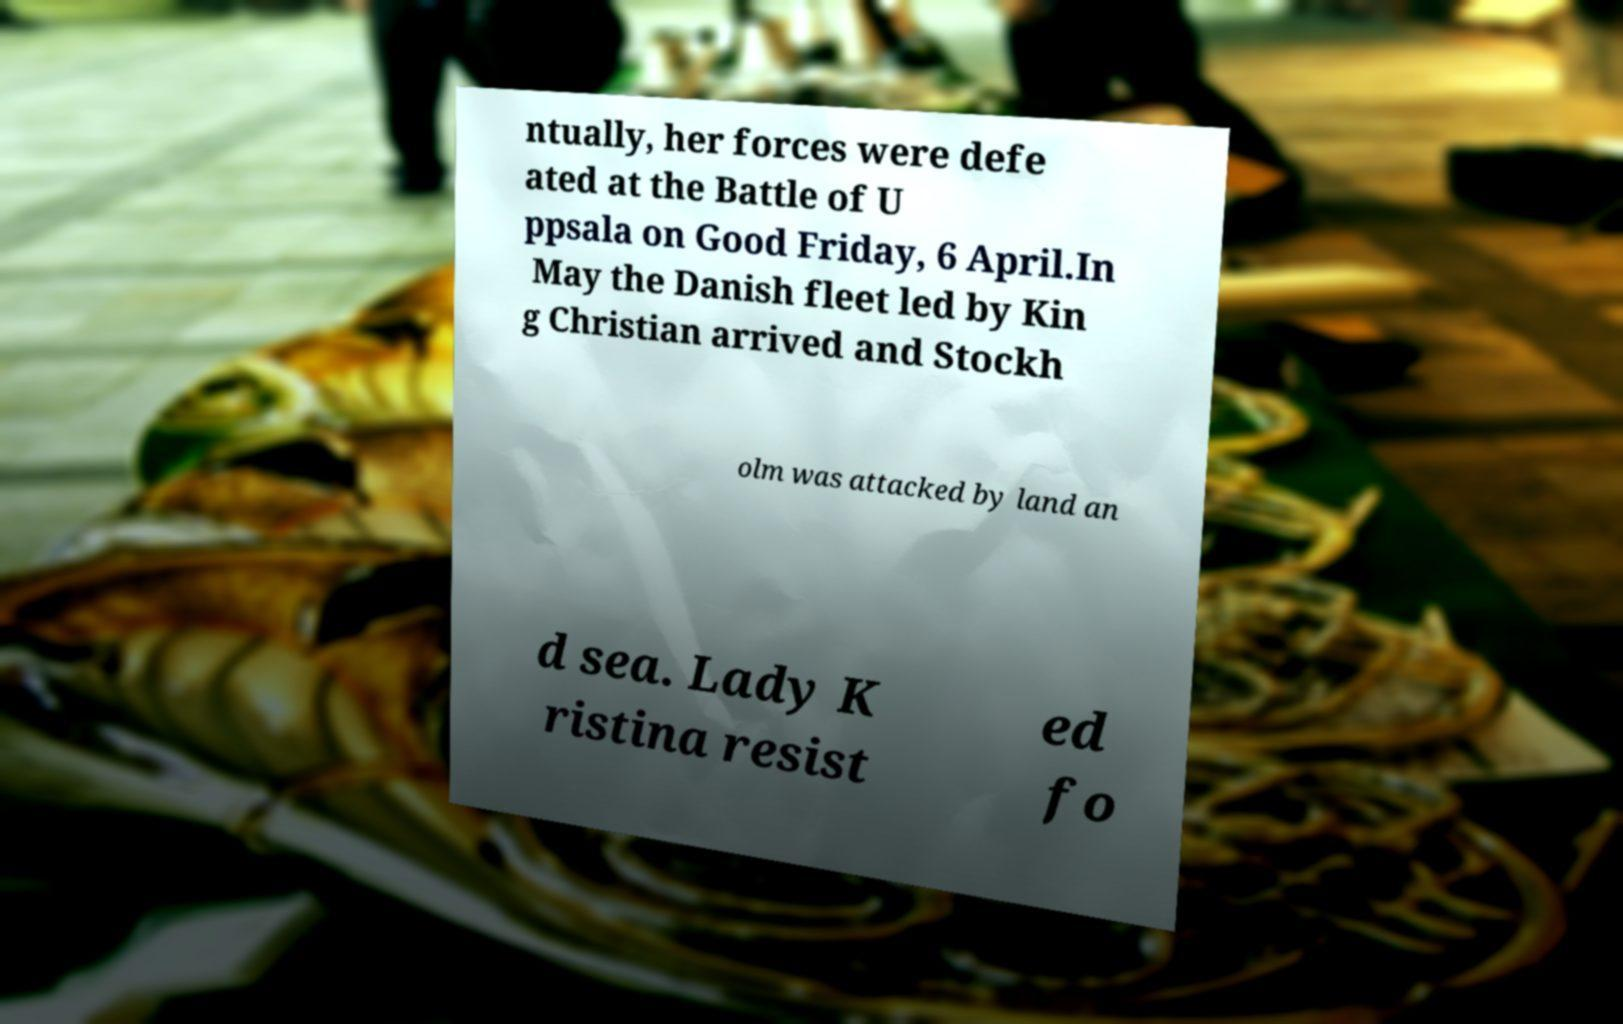Please read and relay the text visible in this image. What does it say? ntually, her forces were defe ated at the Battle of U ppsala on Good Friday, 6 April.In May the Danish fleet led by Kin g Christian arrived and Stockh olm was attacked by land an d sea. Lady K ristina resist ed fo 